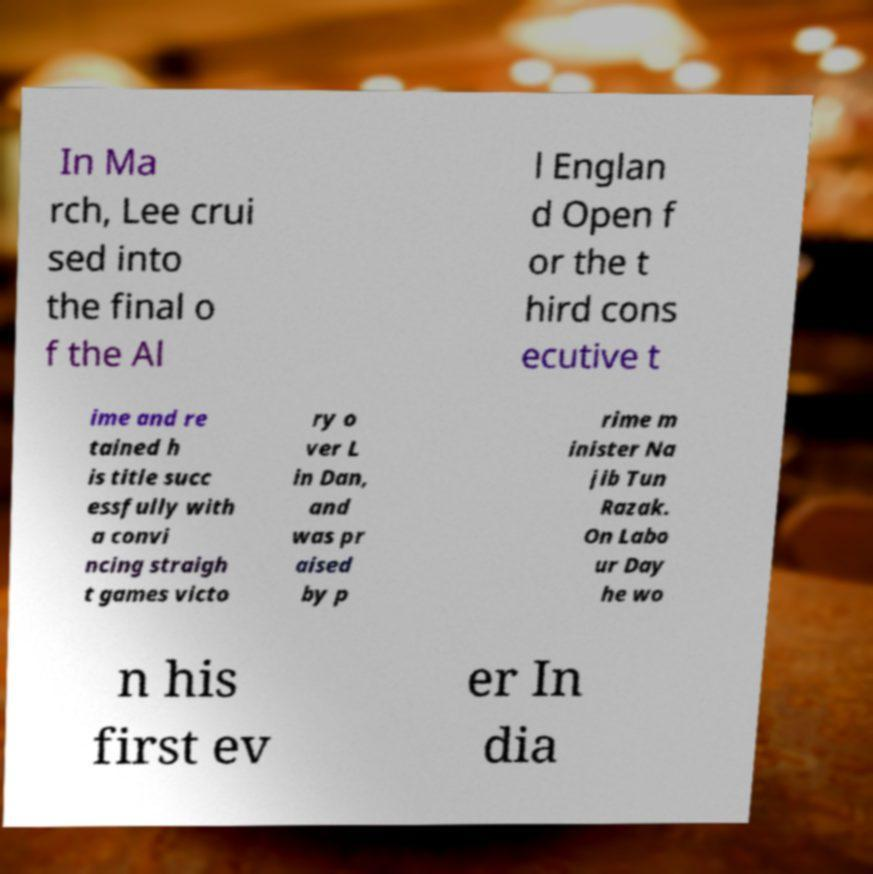There's text embedded in this image that I need extracted. Can you transcribe it verbatim? In Ma rch, Lee crui sed into the final o f the Al l Englan d Open f or the t hird cons ecutive t ime and re tained h is title succ essfully with a convi ncing straigh t games victo ry o ver L in Dan, and was pr aised by p rime m inister Na jib Tun Razak. On Labo ur Day he wo n his first ev er In dia 